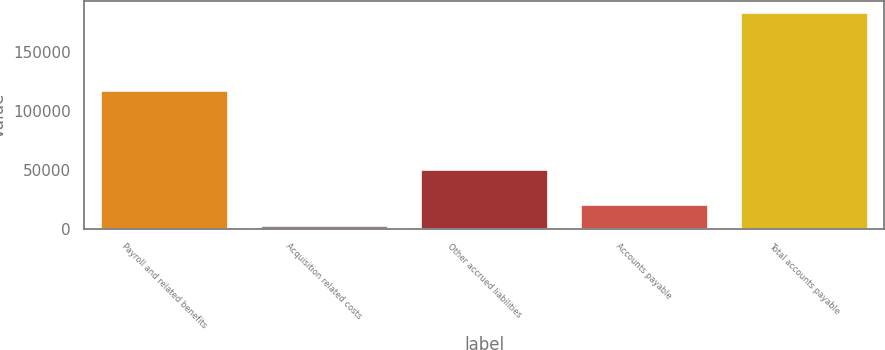<chart> <loc_0><loc_0><loc_500><loc_500><bar_chart><fcel>Payroll and related benefits<fcel>Acquisition related costs<fcel>Other accrued liabilities<fcel>Accounts payable<fcel>Total accounts payable<nl><fcel>117664<fcel>3011<fcel>51193<fcel>21124.5<fcel>184146<nl></chart> 